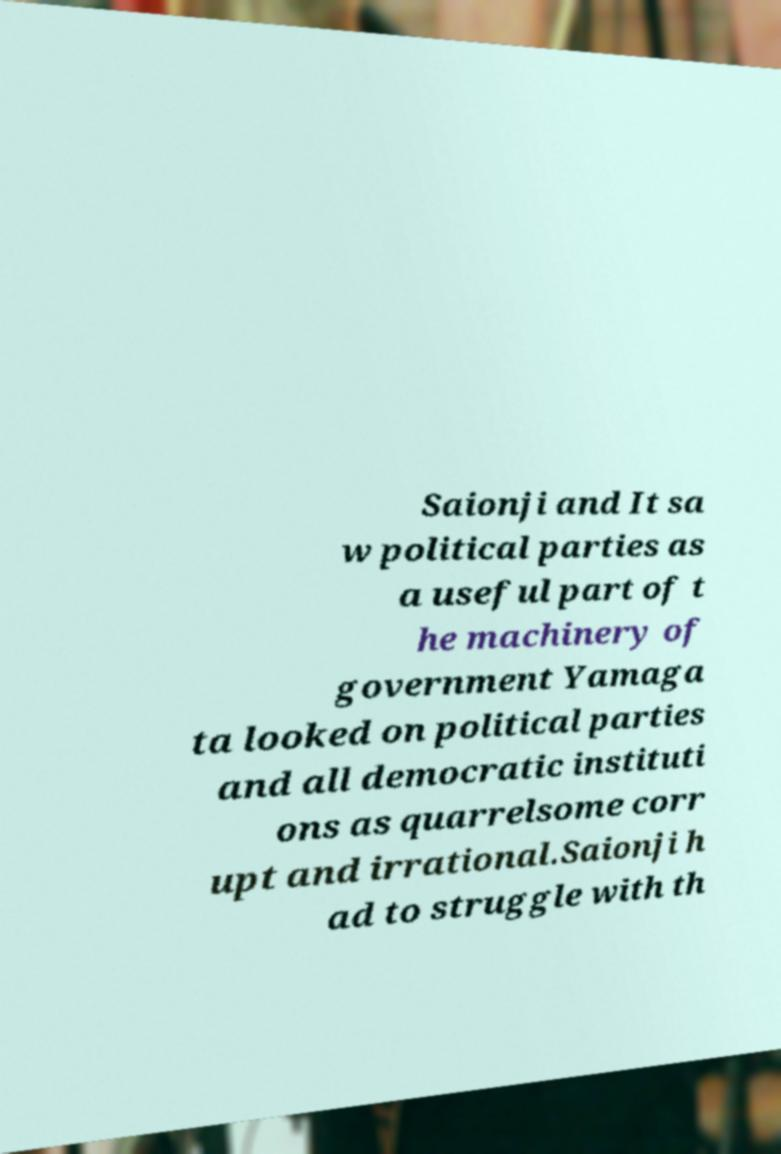Could you assist in decoding the text presented in this image and type it out clearly? Saionji and It sa w political parties as a useful part of t he machinery of government Yamaga ta looked on political parties and all democratic instituti ons as quarrelsome corr upt and irrational.Saionji h ad to struggle with th 